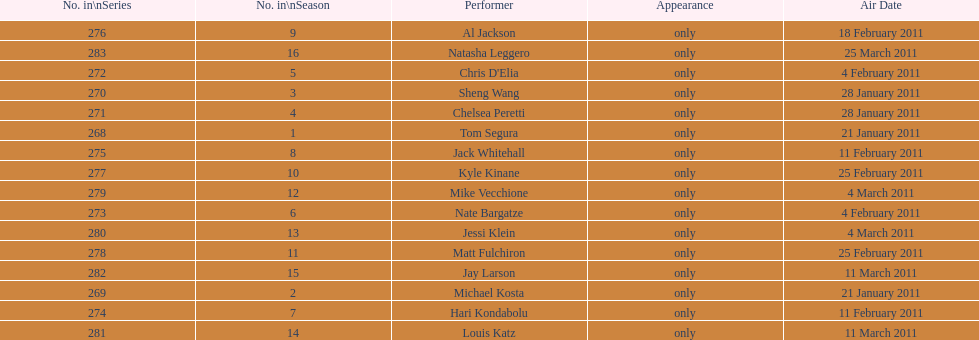Would you mind parsing the complete table? {'header': ['No. in\\nSeries', 'No. in\\nSeason', 'Performer', 'Appearance', 'Air Date'], 'rows': [['276', '9', 'Al Jackson', 'only', '18 February 2011'], ['283', '16', 'Natasha Leggero', 'only', '25 March 2011'], ['272', '5', "Chris D'Elia", 'only', '4 February 2011'], ['270', '3', 'Sheng Wang', 'only', '28 January 2011'], ['271', '4', 'Chelsea Peretti', 'only', '28 January 2011'], ['268', '1', 'Tom Segura', 'only', '21 January 2011'], ['275', '8', 'Jack Whitehall', 'only', '11 February 2011'], ['277', '10', 'Kyle Kinane', 'only', '25 February 2011'], ['279', '12', 'Mike Vecchione', 'only', '4 March 2011'], ['273', '6', 'Nate Bargatze', 'only', '4 February 2011'], ['280', '13', 'Jessi Klein', 'only', '4 March 2011'], ['278', '11', 'Matt Fulchiron', 'only', '25 February 2011'], ['282', '15', 'Jay Larson', 'only', '11 March 2011'], ['269', '2', 'Michael Kosta', 'only', '21 January 2011'], ['274', '7', 'Hari Kondabolu', 'only', '11 February 2011'], ['281', '14', 'Louis Katz', 'only', '11 March 2011']]} How many episodes only had one performer? 16. 